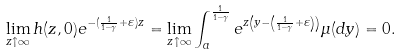<formula> <loc_0><loc_0><loc_500><loc_500>\lim _ { z \uparrow \infty } h ( z , 0 ) e ^ { - ( \frac { 1 } { 1 - \gamma } + \varepsilon ) z } = \lim _ { z \uparrow \infty } \int _ { a } ^ { \frac { 1 } { 1 - \gamma } } e ^ { z \left ( y - \left ( \frac { 1 } { 1 - \gamma } + \varepsilon \right ) \right ) } \mu ( d y ) = 0 .</formula> 